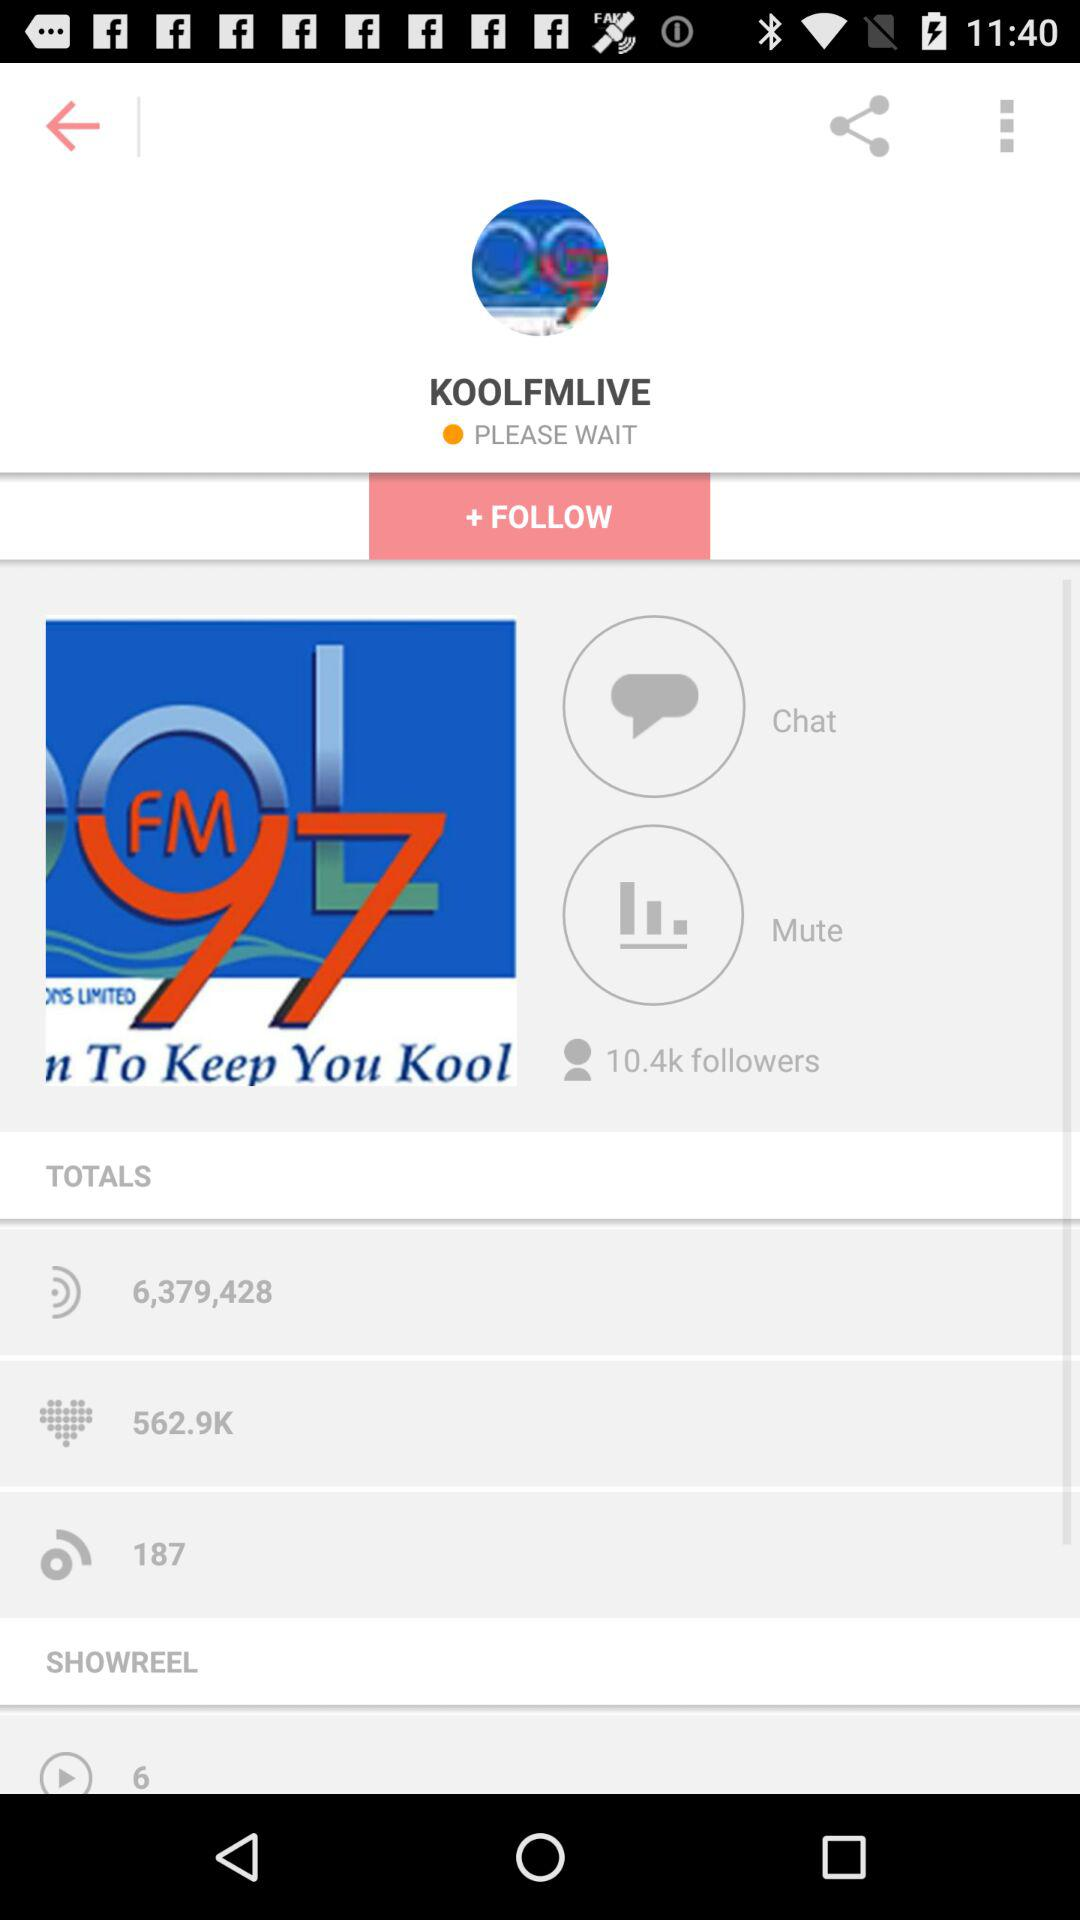How many followers does the account have? The account has 10.4k followers. 